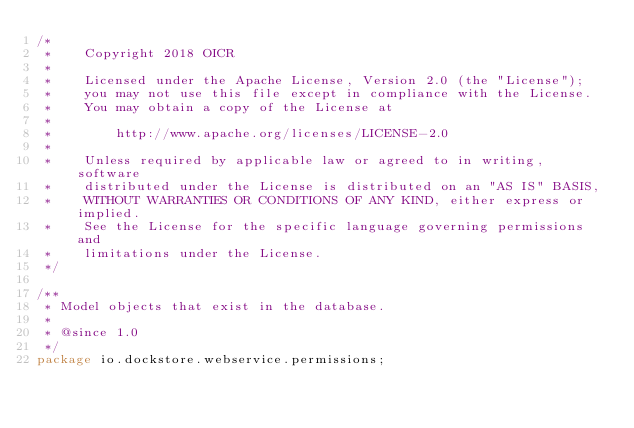<code> <loc_0><loc_0><loc_500><loc_500><_Java_>/*
 *    Copyright 2018 OICR
 *
 *    Licensed under the Apache License, Version 2.0 (the "License");
 *    you may not use this file except in compliance with the License.
 *    You may obtain a copy of the License at
 *
 *        http://www.apache.org/licenses/LICENSE-2.0
 *
 *    Unless required by applicable law or agreed to in writing, software
 *    distributed under the License is distributed on an "AS IS" BASIS,
 *    WITHOUT WARRANTIES OR CONDITIONS OF ANY KIND, either express or implied.
 *    See the License for the specific language governing permissions and
 *    limitations under the License.
 */

/**
 * Model objects that exist in the database.
 *
 * @since 1.0
 */
package io.dockstore.webservice.permissions;

</code> 